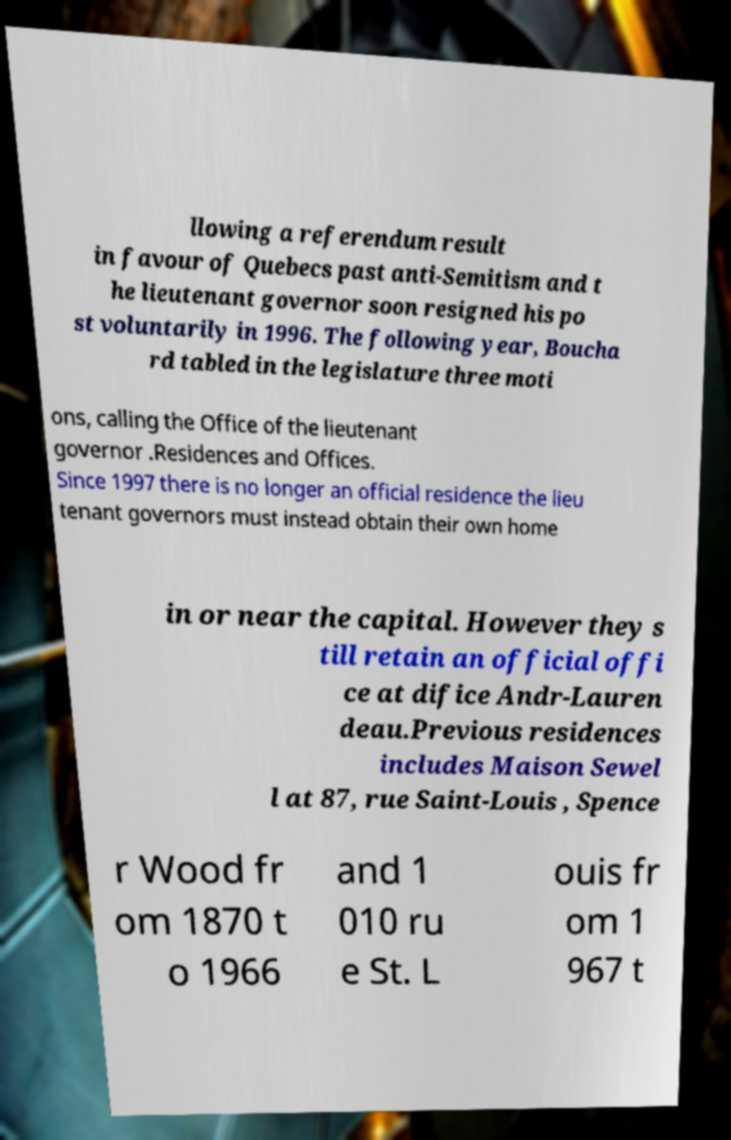What messages or text are displayed in this image? I need them in a readable, typed format. llowing a referendum result in favour of Quebecs past anti-Semitism and t he lieutenant governor soon resigned his po st voluntarily in 1996. The following year, Boucha rd tabled in the legislature three moti ons, calling the Office of the lieutenant governor .Residences and Offices. Since 1997 there is no longer an official residence the lieu tenant governors must instead obtain their own home in or near the capital. However they s till retain an official offi ce at difice Andr-Lauren deau.Previous residences includes Maison Sewel l at 87, rue Saint-Louis , Spence r Wood fr om 1870 t o 1966 and 1 010 ru e St. L ouis fr om 1 967 t 